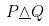<formula> <loc_0><loc_0><loc_500><loc_500>P \underline { \wedge } Q</formula> 